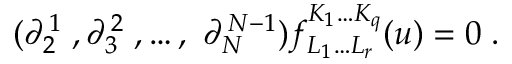<formula> <loc_0><loc_0><loc_500><loc_500>( \partial _ { 2 } ^ { \, 1 } \, , \partial _ { 3 } ^ { \, 2 } \, , \dots , \ \partial _ { N } ^ { \, N - 1 } ) f _ { L _ { 1 } \dots L _ { r } } ^ { K _ { 1 } \dots K _ { q } } ( u ) = 0 \, .</formula> 